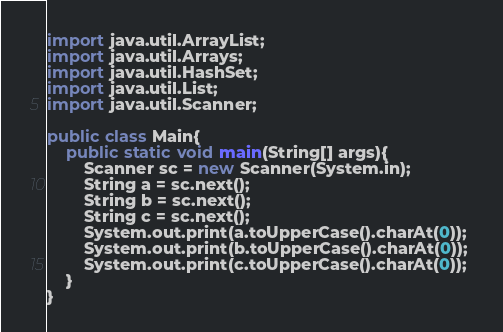Convert code to text. <code><loc_0><loc_0><loc_500><loc_500><_Java_>import java.util.ArrayList;
import java.util.Arrays;
import java.util.HashSet;
import java.util.List;
import java.util.Scanner;

public class Main{
    public static void main(String[] args){
        Scanner sc = new Scanner(System.in);
        String a = sc.next();
        String b = sc.next();
        String c = sc.next();
        System.out.print(a.toUpperCase().charAt(0)); 
        System.out.print(b.toUpperCase().charAt(0)); 
        System.out.print(c.toUpperCase().charAt(0)); 
    }
}

</code> 